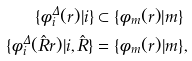<formula> <loc_0><loc_0><loc_500><loc_500>\{ \phi ^ { \Delta } _ { i } ( { r } ) | i \} & \subset \{ \phi _ { m } ( { r } ) | m \} \\ \{ \phi ^ { \Delta } _ { i } ( \hat { R } { r } ) | i , \hat { R } \} & = \{ \phi _ { m } ( { r } ) | m \} ,</formula> 